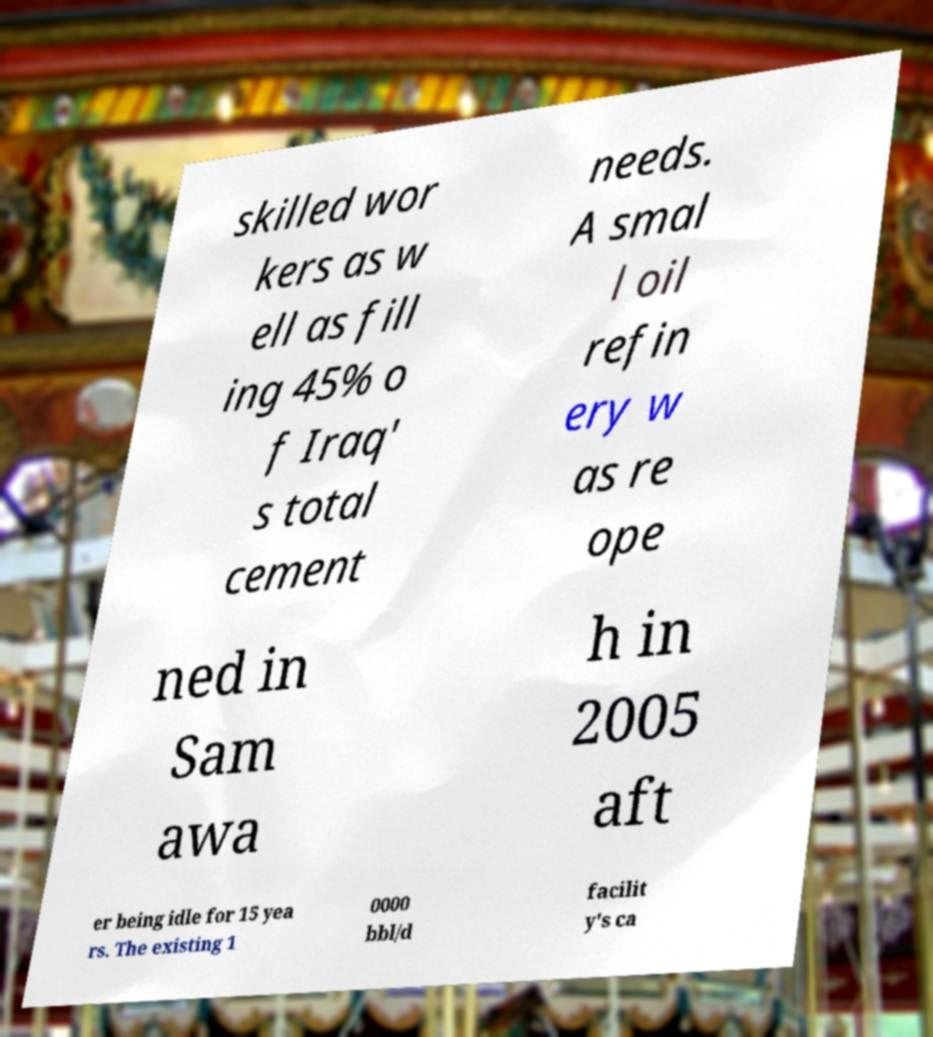Can you read and provide the text displayed in the image?This photo seems to have some interesting text. Can you extract and type it out for me? skilled wor kers as w ell as fill ing 45% o f Iraq' s total cement needs. A smal l oil refin ery w as re ope ned in Sam awa h in 2005 aft er being idle for 15 yea rs. The existing 1 0000 bbl/d facilit y's ca 